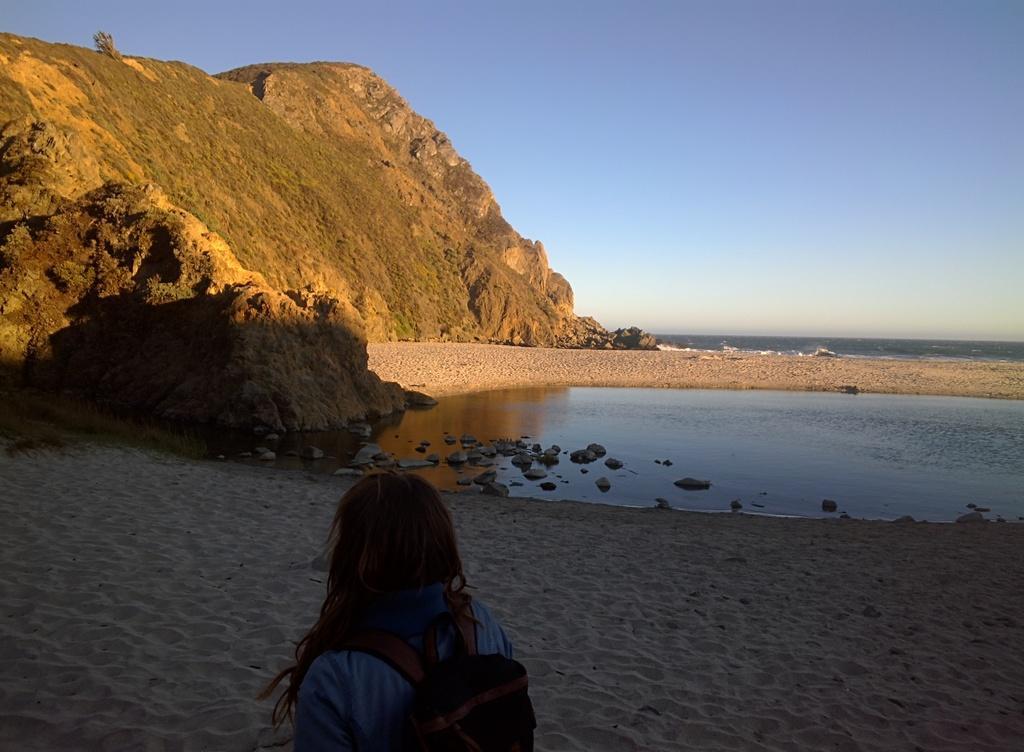Could you give a brief overview of what you see in this image? In this picture we can see a person carrying a bag and in front of this person we can see stones on the water, sand, mountain and in the background we can see the sky. 